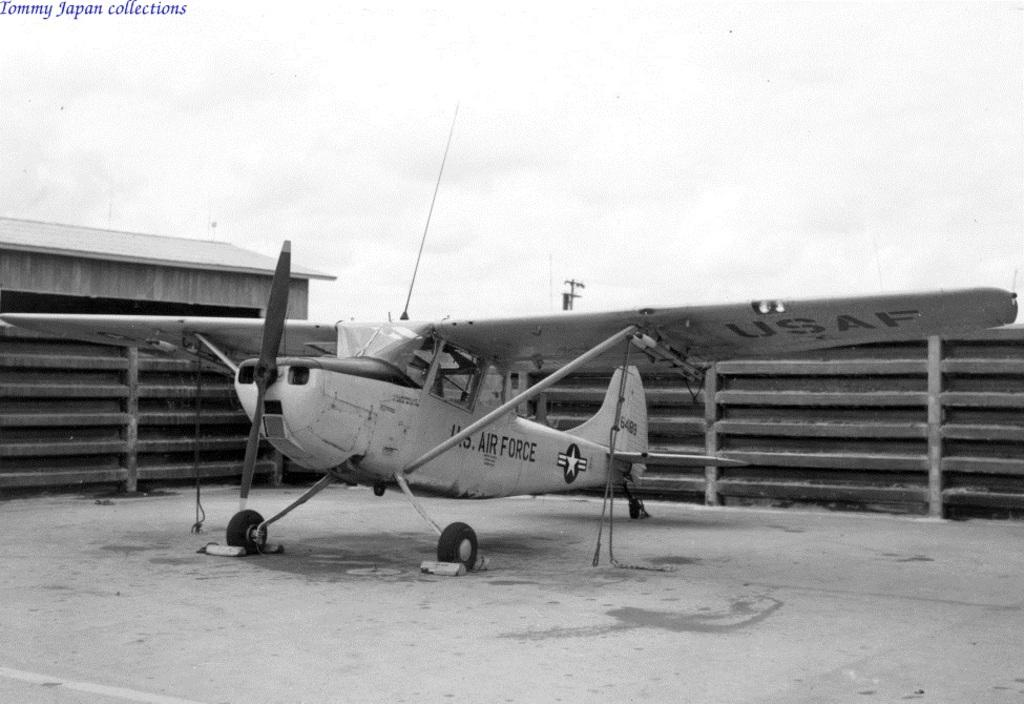<image>
Offer a succinct explanation of the picture presented. U.S. Air Force airplane parked inside a closed area. 